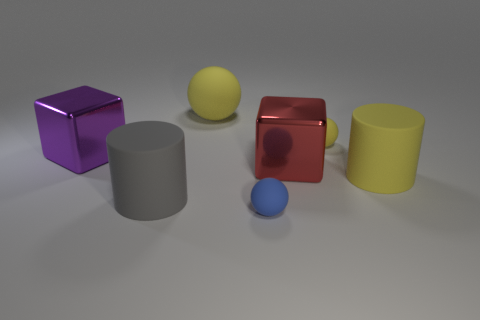There is a big rubber object that is in front of the purple thing and behind the gray matte object; what shape is it?
Provide a short and direct response. Cylinder. Are there any other things that have the same material as the blue thing?
Keep it short and to the point. Yes. Are there an equal number of red metallic cubes and cyan blocks?
Offer a terse response. No. There is a object that is behind the red shiny thing and in front of the small yellow matte thing; what is its material?
Your answer should be very brief. Metal. The red thing that is made of the same material as the purple cube is what shape?
Your answer should be very brief. Cube. Is there anything else that has the same color as the big sphere?
Your response must be concise. Yes. Is the number of large spheres in front of the big gray rubber cylinder greater than the number of big yellow rubber things?
Offer a very short reply. No. What is the material of the red thing?
Your response must be concise. Metal. How many rubber spheres have the same size as the purple object?
Provide a short and direct response. 1. Are there the same number of spheres in front of the small yellow sphere and purple cubes to the left of the small blue thing?
Offer a terse response. Yes. 